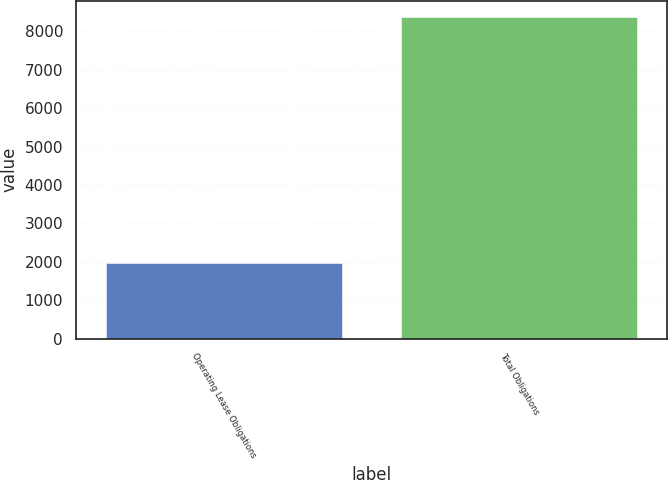Convert chart to OTSL. <chart><loc_0><loc_0><loc_500><loc_500><bar_chart><fcel>Operating Lease Obligations<fcel>Total Obligations<nl><fcel>1960<fcel>8381<nl></chart> 